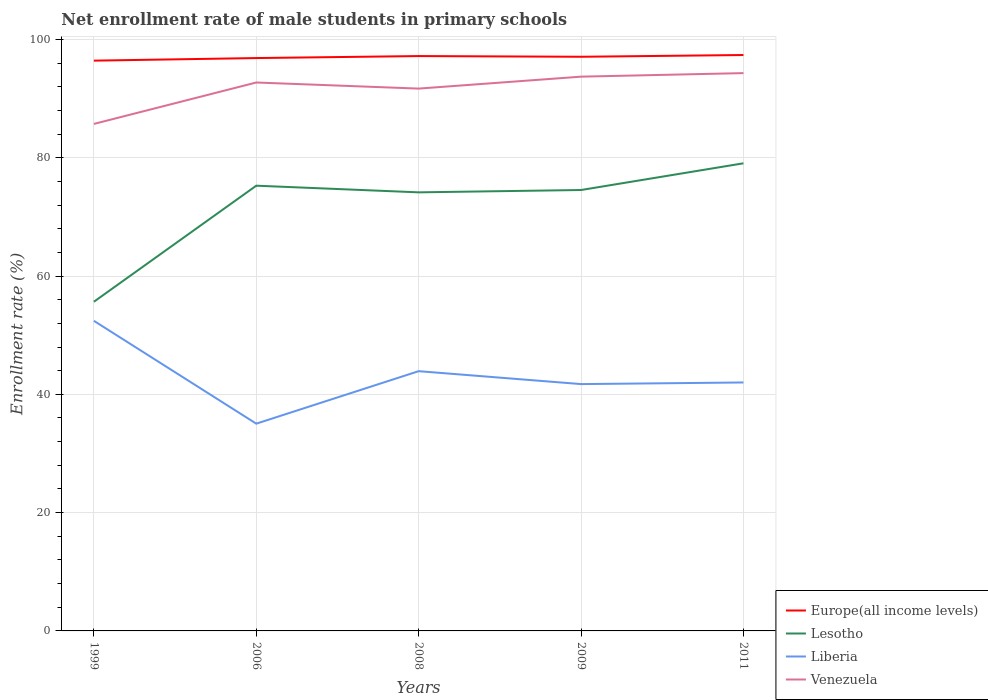Does the line corresponding to Europe(all income levels) intersect with the line corresponding to Lesotho?
Offer a very short reply. No. Across all years, what is the maximum net enrollment rate of male students in primary schools in Europe(all income levels)?
Your answer should be compact. 96.42. In which year was the net enrollment rate of male students in primary schools in Venezuela maximum?
Offer a very short reply. 1999. What is the total net enrollment rate of male students in primary schools in Venezuela in the graph?
Provide a succinct answer. -2.62. What is the difference between the highest and the second highest net enrollment rate of male students in primary schools in Europe(all income levels)?
Your response must be concise. 0.95. How many years are there in the graph?
Your answer should be very brief. 5. Are the values on the major ticks of Y-axis written in scientific E-notation?
Make the answer very short. No. Where does the legend appear in the graph?
Offer a terse response. Bottom right. How are the legend labels stacked?
Your answer should be compact. Vertical. What is the title of the graph?
Your response must be concise. Net enrollment rate of male students in primary schools. Does "Congo (Republic)" appear as one of the legend labels in the graph?
Your answer should be very brief. No. What is the label or title of the X-axis?
Keep it short and to the point. Years. What is the label or title of the Y-axis?
Keep it short and to the point. Enrollment rate (%). What is the Enrollment rate (%) of Europe(all income levels) in 1999?
Provide a short and direct response. 96.42. What is the Enrollment rate (%) of Lesotho in 1999?
Your answer should be compact. 55.65. What is the Enrollment rate (%) of Liberia in 1999?
Give a very brief answer. 52.43. What is the Enrollment rate (%) of Venezuela in 1999?
Your answer should be compact. 85.72. What is the Enrollment rate (%) in Europe(all income levels) in 2006?
Provide a short and direct response. 96.86. What is the Enrollment rate (%) in Lesotho in 2006?
Make the answer very short. 75.28. What is the Enrollment rate (%) of Liberia in 2006?
Offer a terse response. 35.04. What is the Enrollment rate (%) in Venezuela in 2006?
Make the answer very short. 92.72. What is the Enrollment rate (%) in Europe(all income levels) in 2008?
Your answer should be compact. 97.19. What is the Enrollment rate (%) in Lesotho in 2008?
Offer a very short reply. 74.15. What is the Enrollment rate (%) in Liberia in 2008?
Offer a very short reply. 43.92. What is the Enrollment rate (%) of Venezuela in 2008?
Ensure brevity in your answer.  91.69. What is the Enrollment rate (%) of Europe(all income levels) in 2009?
Offer a terse response. 97.08. What is the Enrollment rate (%) in Lesotho in 2009?
Your response must be concise. 74.55. What is the Enrollment rate (%) of Liberia in 2009?
Provide a short and direct response. 41.73. What is the Enrollment rate (%) in Venezuela in 2009?
Your response must be concise. 93.71. What is the Enrollment rate (%) of Europe(all income levels) in 2011?
Offer a very short reply. 97.37. What is the Enrollment rate (%) in Lesotho in 2011?
Offer a very short reply. 79.06. What is the Enrollment rate (%) in Liberia in 2011?
Give a very brief answer. 42.01. What is the Enrollment rate (%) of Venezuela in 2011?
Ensure brevity in your answer.  94.31. Across all years, what is the maximum Enrollment rate (%) of Europe(all income levels)?
Ensure brevity in your answer.  97.37. Across all years, what is the maximum Enrollment rate (%) of Lesotho?
Your answer should be compact. 79.06. Across all years, what is the maximum Enrollment rate (%) in Liberia?
Ensure brevity in your answer.  52.43. Across all years, what is the maximum Enrollment rate (%) in Venezuela?
Ensure brevity in your answer.  94.31. Across all years, what is the minimum Enrollment rate (%) in Europe(all income levels)?
Offer a terse response. 96.42. Across all years, what is the minimum Enrollment rate (%) in Lesotho?
Ensure brevity in your answer.  55.65. Across all years, what is the minimum Enrollment rate (%) of Liberia?
Provide a short and direct response. 35.04. Across all years, what is the minimum Enrollment rate (%) in Venezuela?
Provide a succinct answer. 85.72. What is the total Enrollment rate (%) of Europe(all income levels) in the graph?
Give a very brief answer. 484.92. What is the total Enrollment rate (%) of Lesotho in the graph?
Provide a succinct answer. 358.69. What is the total Enrollment rate (%) in Liberia in the graph?
Ensure brevity in your answer.  215.13. What is the total Enrollment rate (%) of Venezuela in the graph?
Keep it short and to the point. 458.16. What is the difference between the Enrollment rate (%) of Europe(all income levels) in 1999 and that in 2006?
Give a very brief answer. -0.43. What is the difference between the Enrollment rate (%) in Lesotho in 1999 and that in 2006?
Ensure brevity in your answer.  -19.63. What is the difference between the Enrollment rate (%) in Liberia in 1999 and that in 2006?
Your answer should be compact. 17.39. What is the difference between the Enrollment rate (%) in Venezuela in 1999 and that in 2006?
Ensure brevity in your answer.  -7. What is the difference between the Enrollment rate (%) in Europe(all income levels) in 1999 and that in 2008?
Give a very brief answer. -0.77. What is the difference between the Enrollment rate (%) in Lesotho in 1999 and that in 2008?
Provide a short and direct response. -18.5. What is the difference between the Enrollment rate (%) of Liberia in 1999 and that in 2008?
Your response must be concise. 8.51. What is the difference between the Enrollment rate (%) of Venezuela in 1999 and that in 2008?
Your answer should be very brief. -5.97. What is the difference between the Enrollment rate (%) in Europe(all income levels) in 1999 and that in 2009?
Provide a short and direct response. -0.66. What is the difference between the Enrollment rate (%) in Lesotho in 1999 and that in 2009?
Offer a terse response. -18.89. What is the difference between the Enrollment rate (%) of Liberia in 1999 and that in 2009?
Provide a short and direct response. 10.7. What is the difference between the Enrollment rate (%) in Venezuela in 1999 and that in 2009?
Ensure brevity in your answer.  -7.99. What is the difference between the Enrollment rate (%) in Europe(all income levels) in 1999 and that in 2011?
Your answer should be compact. -0.95. What is the difference between the Enrollment rate (%) in Lesotho in 1999 and that in 2011?
Make the answer very short. -23.41. What is the difference between the Enrollment rate (%) in Liberia in 1999 and that in 2011?
Give a very brief answer. 10.42. What is the difference between the Enrollment rate (%) in Venezuela in 1999 and that in 2011?
Keep it short and to the point. -8.59. What is the difference between the Enrollment rate (%) in Europe(all income levels) in 2006 and that in 2008?
Ensure brevity in your answer.  -0.34. What is the difference between the Enrollment rate (%) of Lesotho in 2006 and that in 2008?
Make the answer very short. 1.13. What is the difference between the Enrollment rate (%) in Liberia in 2006 and that in 2008?
Give a very brief answer. -8.88. What is the difference between the Enrollment rate (%) in Venezuela in 2006 and that in 2008?
Offer a terse response. 1.03. What is the difference between the Enrollment rate (%) of Europe(all income levels) in 2006 and that in 2009?
Provide a short and direct response. -0.22. What is the difference between the Enrollment rate (%) of Lesotho in 2006 and that in 2009?
Your answer should be very brief. 0.73. What is the difference between the Enrollment rate (%) in Liberia in 2006 and that in 2009?
Offer a very short reply. -6.69. What is the difference between the Enrollment rate (%) of Venezuela in 2006 and that in 2009?
Ensure brevity in your answer.  -0.99. What is the difference between the Enrollment rate (%) of Europe(all income levels) in 2006 and that in 2011?
Your answer should be very brief. -0.52. What is the difference between the Enrollment rate (%) in Lesotho in 2006 and that in 2011?
Your answer should be very brief. -3.78. What is the difference between the Enrollment rate (%) in Liberia in 2006 and that in 2011?
Keep it short and to the point. -6.97. What is the difference between the Enrollment rate (%) in Venezuela in 2006 and that in 2011?
Your answer should be compact. -1.59. What is the difference between the Enrollment rate (%) in Europe(all income levels) in 2008 and that in 2009?
Provide a short and direct response. 0.12. What is the difference between the Enrollment rate (%) of Lesotho in 2008 and that in 2009?
Ensure brevity in your answer.  -0.39. What is the difference between the Enrollment rate (%) of Liberia in 2008 and that in 2009?
Provide a short and direct response. 2.18. What is the difference between the Enrollment rate (%) in Venezuela in 2008 and that in 2009?
Your response must be concise. -2.02. What is the difference between the Enrollment rate (%) of Europe(all income levels) in 2008 and that in 2011?
Ensure brevity in your answer.  -0.18. What is the difference between the Enrollment rate (%) of Lesotho in 2008 and that in 2011?
Provide a short and direct response. -4.91. What is the difference between the Enrollment rate (%) in Liberia in 2008 and that in 2011?
Give a very brief answer. 1.91. What is the difference between the Enrollment rate (%) of Venezuela in 2008 and that in 2011?
Provide a short and direct response. -2.62. What is the difference between the Enrollment rate (%) of Europe(all income levels) in 2009 and that in 2011?
Give a very brief answer. -0.3. What is the difference between the Enrollment rate (%) in Lesotho in 2009 and that in 2011?
Your answer should be very brief. -4.51. What is the difference between the Enrollment rate (%) of Liberia in 2009 and that in 2011?
Your answer should be compact. -0.28. What is the difference between the Enrollment rate (%) of Europe(all income levels) in 1999 and the Enrollment rate (%) of Lesotho in 2006?
Provide a short and direct response. 21.14. What is the difference between the Enrollment rate (%) of Europe(all income levels) in 1999 and the Enrollment rate (%) of Liberia in 2006?
Offer a terse response. 61.38. What is the difference between the Enrollment rate (%) of Europe(all income levels) in 1999 and the Enrollment rate (%) of Venezuela in 2006?
Provide a short and direct response. 3.7. What is the difference between the Enrollment rate (%) in Lesotho in 1999 and the Enrollment rate (%) in Liberia in 2006?
Make the answer very short. 20.61. What is the difference between the Enrollment rate (%) in Lesotho in 1999 and the Enrollment rate (%) in Venezuela in 2006?
Give a very brief answer. -37.07. What is the difference between the Enrollment rate (%) of Liberia in 1999 and the Enrollment rate (%) of Venezuela in 2006?
Your answer should be very brief. -40.29. What is the difference between the Enrollment rate (%) in Europe(all income levels) in 1999 and the Enrollment rate (%) in Lesotho in 2008?
Your response must be concise. 22.27. What is the difference between the Enrollment rate (%) in Europe(all income levels) in 1999 and the Enrollment rate (%) in Liberia in 2008?
Your answer should be compact. 52.5. What is the difference between the Enrollment rate (%) of Europe(all income levels) in 1999 and the Enrollment rate (%) of Venezuela in 2008?
Ensure brevity in your answer.  4.73. What is the difference between the Enrollment rate (%) of Lesotho in 1999 and the Enrollment rate (%) of Liberia in 2008?
Offer a very short reply. 11.74. What is the difference between the Enrollment rate (%) in Lesotho in 1999 and the Enrollment rate (%) in Venezuela in 2008?
Offer a terse response. -36.04. What is the difference between the Enrollment rate (%) in Liberia in 1999 and the Enrollment rate (%) in Venezuela in 2008?
Give a very brief answer. -39.26. What is the difference between the Enrollment rate (%) in Europe(all income levels) in 1999 and the Enrollment rate (%) in Lesotho in 2009?
Your answer should be very brief. 21.87. What is the difference between the Enrollment rate (%) of Europe(all income levels) in 1999 and the Enrollment rate (%) of Liberia in 2009?
Keep it short and to the point. 54.69. What is the difference between the Enrollment rate (%) of Europe(all income levels) in 1999 and the Enrollment rate (%) of Venezuela in 2009?
Provide a short and direct response. 2.71. What is the difference between the Enrollment rate (%) of Lesotho in 1999 and the Enrollment rate (%) of Liberia in 2009?
Make the answer very short. 13.92. What is the difference between the Enrollment rate (%) in Lesotho in 1999 and the Enrollment rate (%) in Venezuela in 2009?
Your response must be concise. -38.06. What is the difference between the Enrollment rate (%) in Liberia in 1999 and the Enrollment rate (%) in Venezuela in 2009?
Ensure brevity in your answer.  -41.28. What is the difference between the Enrollment rate (%) in Europe(all income levels) in 1999 and the Enrollment rate (%) in Lesotho in 2011?
Your response must be concise. 17.36. What is the difference between the Enrollment rate (%) in Europe(all income levels) in 1999 and the Enrollment rate (%) in Liberia in 2011?
Provide a short and direct response. 54.41. What is the difference between the Enrollment rate (%) of Europe(all income levels) in 1999 and the Enrollment rate (%) of Venezuela in 2011?
Your answer should be compact. 2.11. What is the difference between the Enrollment rate (%) of Lesotho in 1999 and the Enrollment rate (%) of Liberia in 2011?
Offer a terse response. 13.65. What is the difference between the Enrollment rate (%) in Lesotho in 1999 and the Enrollment rate (%) in Venezuela in 2011?
Offer a very short reply. -38.66. What is the difference between the Enrollment rate (%) in Liberia in 1999 and the Enrollment rate (%) in Venezuela in 2011?
Offer a terse response. -41.88. What is the difference between the Enrollment rate (%) of Europe(all income levels) in 2006 and the Enrollment rate (%) of Lesotho in 2008?
Give a very brief answer. 22.7. What is the difference between the Enrollment rate (%) of Europe(all income levels) in 2006 and the Enrollment rate (%) of Liberia in 2008?
Ensure brevity in your answer.  52.94. What is the difference between the Enrollment rate (%) in Europe(all income levels) in 2006 and the Enrollment rate (%) in Venezuela in 2008?
Offer a terse response. 5.16. What is the difference between the Enrollment rate (%) in Lesotho in 2006 and the Enrollment rate (%) in Liberia in 2008?
Give a very brief answer. 31.36. What is the difference between the Enrollment rate (%) of Lesotho in 2006 and the Enrollment rate (%) of Venezuela in 2008?
Your answer should be compact. -16.41. What is the difference between the Enrollment rate (%) in Liberia in 2006 and the Enrollment rate (%) in Venezuela in 2008?
Make the answer very short. -56.65. What is the difference between the Enrollment rate (%) in Europe(all income levels) in 2006 and the Enrollment rate (%) in Lesotho in 2009?
Give a very brief answer. 22.31. What is the difference between the Enrollment rate (%) of Europe(all income levels) in 2006 and the Enrollment rate (%) of Liberia in 2009?
Keep it short and to the point. 55.12. What is the difference between the Enrollment rate (%) of Europe(all income levels) in 2006 and the Enrollment rate (%) of Venezuela in 2009?
Ensure brevity in your answer.  3.14. What is the difference between the Enrollment rate (%) in Lesotho in 2006 and the Enrollment rate (%) in Liberia in 2009?
Your response must be concise. 33.55. What is the difference between the Enrollment rate (%) of Lesotho in 2006 and the Enrollment rate (%) of Venezuela in 2009?
Offer a very short reply. -18.43. What is the difference between the Enrollment rate (%) in Liberia in 2006 and the Enrollment rate (%) in Venezuela in 2009?
Ensure brevity in your answer.  -58.67. What is the difference between the Enrollment rate (%) of Europe(all income levels) in 2006 and the Enrollment rate (%) of Lesotho in 2011?
Keep it short and to the point. 17.79. What is the difference between the Enrollment rate (%) in Europe(all income levels) in 2006 and the Enrollment rate (%) in Liberia in 2011?
Keep it short and to the point. 54.85. What is the difference between the Enrollment rate (%) in Europe(all income levels) in 2006 and the Enrollment rate (%) in Venezuela in 2011?
Your answer should be very brief. 2.54. What is the difference between the Enrollment rate (%) in Lesotho in 2006 and the Enrollment rate (%) in Liberia in 2011?
Your answer should be compact. 33.27. What is the difference between the Enrollment rate (%) of Lesotho in 2006 and the Enrollment rate (%) of Venezuela in 2011?
Your response must be concise. -19.03. What is the difference between the Enrollment rate (%) in Liberia in 2006 and the Enrollment rate (%) in Venezuela in 2011?
Make the answer very short. -59.27. What is the difference between the Enrollment rate (%) in Europe(all income levels) in 2008 and the Enrollment rate (%) in Lesotho in 2009?
Make the answer very short. 22.65. What is the difference between the Enrollment rate (%) in Europe(all income levels) in 2008 and the Enrollment rate (%) in Liberia in 2009?
Keep it short and to the point. 55.46. What is the difference between the Enrollment rate (%) of Europe(all income levels) in 2008 and the Enrollment rate (%) of Venezuela in 2009?
Provide a succinct answer. 3.48. What is the difference between the Enrollment rate (%) in Lesotho in 2008 and the Enrollment rate (%) in Liberia in 2009?
Keep it short and to the point. 32.42. What is the difference between the Enrollment rate (%) of Lesotho in 2008 and the Enrollment rate (%) of Venezuela in 2009?
Offer a very short reply. -19.56. What is the difference between the Enrollment rate (%) of Liberia in 2008 and the Enrollment rate (%) of Venezuela in 2009?
Offer a very short reply. -49.8. What is the difference between the Enrollment rate (%) in Europe(all income levels) in 2008 and the Enrollment rate (%) in Lesotho in 2011?
Your answer should be compact. 18.13. What is the difference between the Enrollment rate (%) of Europe(all income levels) in 2008 and the Enrollment rate (%) of Liberia in 2011?
Keep it short and to the point. 55.19. What is the difference between the Enrollment rate (%) in Europe(all income levels) in 2008 and the Enrollment rate (%) in Venezuela in 2011?
Make the answer very short. 2.88. What is the difference between the Enrollment rate (%) of Lesotho in 2008 and the Enrollment rate (%) of Liberia in 2011?
Your answer should be compact. 32.15. What is the difference between the Enrollment rate (%) of Lesotho in 2008 and the Enrollment rate (%) of Venezuela in 2011?
Provide a short and direct response. -20.16. What is the difference between the Enrollment rate (%) in Liberia in 2008 and the Enrollment rate (%) in Venezuela in 2011?
Give a very brief answer. -50.4. What is the difference between the Enrollment rate (%) of Europe(all income levels) in 2009 and the Enrollment rate (%) of Lesotho in 2011?
Your response must be concise. 18.01. What is the difference between the Enrollment rate (%) of Europe(all income levels) in 2009 and the Enrollment rate (%) of Liberia in 2011?
Your answer should be compact. 55.07. What is the difference between the Enrollment rate (%) in Europe(all income levels) in 2009 and the Enrollment rate (%) in Venezuela in 2011?
Ensure brevity in your answer.  2.76. What is the difference between the Enrollment rate (%) in Lesotho in 2009 and the Enrollment rate (%) in Liberia in 2011?
Offer a very short reply. 32.54. What is the difference between the Enrollment rate (%) in Lesotho in 2009 and the Enrollment rate (%) in Venezuela in 2011?
Give a very brief answer. -19.76. What is the difference between the Enrollment rate (%) in Liberia in 2009 and the Enrollment rate (%) in Venezuela in 2011?
Make the answer very short. -52.58. What is the average Enrollment rate (%) of Europe(all income levels) per year?
Give a very brief answer. 96.98. What is the average Enrollment rate (%) in Lesotho per year?
Ensure brevity in your answer.  71.74. What is the average Enrollment rate (%) of Liberia per year?
Ensure brevity in your answer.  43.03. What is the average Enrollment rate (%) in Venezuela per year?
Give a very brief answer. 91.63. In the year 1999, what is the difference between the Enrollment rate (%) of Europe(all income levels) and Enrollment rate (%) of Lesotho?
Provide a succinct answer. 40.77. In the year 1999, what is the difference between the Enrollment rate (%) in Europe(all income levels) and Enrollment rate (%) in Liberia?
Provide a succinct answer. 43.99. In the year 1999, what is the difference between the Enrollment rate (%) in Europe(all income levels) and Enrollment rate (%) in Venezuela?
Offer a very short reply. 10.7. In the year 1999, what is the difference between the Enrollment rate (%) in Lesotho and Enrollment rate (%) in Liberia?
Your answer should be compact. 3.22. In the year 1999, what is the difference between the Enrollment rate (%) in Lesotho and Enrollment rate (%) in Venezuela?
Ensure brevity in your answer.  -30.07. In the year 1999, what is the difference between the Enrollment rate (%) of Liberia and Enrollment rate (%) of Venezuela?
Make the answer very short. -33.29. In the year 2006, what is the difference between the Enrollment rate (%) of Europe(all income levels) and Enrollment rate (%) of Lesotho?
Give a very brief answer. 21.58. In the year 2006, what is the difference between the Enrollment rate (%) in Europe(all income levels) and Enrollment rate (%) in Liberia?
Give a very brief answer. 61.81. In the year 2006, what is the difference between the Enrollment rate (%) of Europe(all income levels) and Enrollment rate (%) of Venezuela?
Provide a succinct answer. 4.13. In the year 2006, what is the difference between the Enrollment rate (%) of Lesotho and Enrollment rate (%) of Liberia?
Offer a very short reply. 40.24. In the year 2006, what is the difference between the Enrollment rate (%) in Lesotho and Enrollment rate (%) in Venezuela?
Provide a short and direct response. -17.45. In the year 2006, what is the difference between the Enrollment rate (%) in Liberia and Enrollment rate (%) in Venezuela?
Your response must be concise. -57.68. In the year 2008, what is the difference between the Enrollment rate (%) of Europe(all income levels) and Enrollment rate (%) of Lesotho?
Provide a short and direct response. 23.04. In the year 2008, what is the difference between the Enrollment rate (%) of Europe(all income levels) and Enrollment rate (%) of Liberia?
Your answer should be compact. 53.28. In the year 2008, what is the difference between the Enrollment rate (%) in Europe(all income levels) and Enrollment rate (%) in Venezuela?
Your answer should be very brief. 5.5. In the year 2008, what is the difference between the Enrollment rate (%) of Lesotho and Enrollment rate (%) of Liberia?
Make the answer very short. 30.24. In the year 2008, what is the difference between the Enrollment rate (%) in Lesotho and Enrollment rate (%) in Venezuela?
Make the answer very short. -17.54. In the year 2008, what is the difference between the Enrollment rate (%) in Liberia and Enrollment rate (%) in Venezuela?
Ensure brevity in your answer.  -47.78. In the year 2009, what is the difference between the Enrollment rate (%) of Europe(all income levels) and Enrollment rate (%) of Lesotho?
Offer a very short reply. 22.53. In the year 2009, what is the difference between the Enrollment rate (%) of Europe(all income levels) and Enrollment rate (%) of Liberia?
Ensure brevity in your answer.  55.34. In the year 2009, what is the difference between the Enrollment rate (%) of Europe(all income levels) and Enrollment rate (%) of Venezuela?
Your response must be concise. 3.36. In the year 2009, what is the difference between the Enrollment rate (%) in Lesotho and Enrollment rate (%) in Liberia?
Your answer should be compact. 32.82. In the year 2009, what is the difference between the Enrollment rate (%) of Lesotho and Enrollment rate (%) of Venezuela?
Give a very brief answer. -19.16. In the year 2009, what is the difference between the Enrollment rate (%) of Liberia and Enrollment rate (%) of Venezuela?
Provide a succinct answer. -51.98. In the year 2011, what is the difference between the Enrollment rate (%) in Europe(all income levels) and Enrollment rate (%) in Lesotho?
Make the answer very short. 18.31. In the year 2011, what is the difference between the Enrollment rate (%) in Europe(all income levels) and Enrollment rate (%) in Liberia?
Give a very brief answer. 55.36. In the year 2011, what is the difference between the Enrollment rate (%) of Europe(all income levels) and Enrollment rate (%) of Venezuela?
Your answer should be very brief. 3.06. In the year 2011, what is the difference between the Enrollment rate (%) in Lesotho and Enrollment rate (%) in Liberia?
Keep it short and to the point. 37.05. In the year 2011, what is the difference between the Enrollment rate (%) of Lesotho and Enrollment rate (%) of Venezuela?
Your response must be concise. -15.25. In the year 2011, what is the difference between the Enrollment rate (%) in Liberia and Enrollment rate (%) in Venezuela?
Offer a terse response. -52.3. What is the ratio of the Enrollment rate (%) of Europe(all income levels) in 1999 to that in 2006?
Your response must be concise. 1. What is the ratio of the Enrollment rate (%) of Lesotho in 1999 to that in 2006?
Your answer should be compact. 0.74. What is the ratio of the Enrollment rate (%) in Liberia in 1999 to that in 2006?
Your response must be concise. 1.5. What is the ratio of the Enrollment rate (%) of Venezuela in 1999 to that in 2006?
Your answer should be very brief. 0.92. What is the ratio of the Enrollment rate (%) in Europe(all income levels) in 1999 to that in 2008?
Your answer should be very brief. 0.99. What is the ratio of the Enrollment rate (%) of Lesotho in 1999 to that in 2008?
Offer a terse response. 0.75. What is the ratio of the Enrollment rate (%) of Liberia in 1999 to that in 2008?
Your answer should be compact. 1.19. What is the ratio of the Enrollment rate (%) in Venezuela in 1999 to that in 2008?
Offer a terse response. 0.93. What is the ratio of the Enrollment rate (%) in Lesotho in 1999 to that in 2009?
Ensure brevity in your answer.  0.75. What is the ratio of the Enrollment rate (%) of Liberia in 1999 to that in 2009?
Your response must be concise. 1.26. What is the ratio of the Enrollment rate (%) of Venezuela in 1999 to that in 2009?
Your answer should be compact. 0.91. What is the ratio of the Enrollment rate (%) in Europe(all income levels) in 1999 to that in 2011?
Your response must be concise. 0.99. What is the ratio of the Enrollment rate (%) of Lesotho in 1999 to that in 2011?
Make the answer very short. 0.7. What is the ratio of the Enrollment rate (%) in Liberia in 1999 to that in 2011?
Give a very brief answer. 1.25. What is the ratio of the Enrollment rate (%) of Venezuela in 1999 to that in 2011?
Your answer should be very brief. 0.91. What is the ratio of the Enrollment rate (%) of Lesotho in 2006 to that in 2008?
Your answer should be very brief. 1.02. What is the ratio of the Enrollment rate (%) in Liberia in 2006 to that in 2008?
Keep it short and to the point. 0.8. What is the ratio of the Enrollment rate (%) of Venezuela in 2006 to that in 2008?
Give a very brief answer. 1.01. What is the ratio of the Enrollment rate (%) of Europe(all income levels) in 2006 to that in 2009?
Provide a short and direct response. 1. What is the ratio of the Enrollment rate (%) of Lesotho in 2006 to that in 2009?
Make the answer very short. 1.01. What is the ratio of the Enrollment rate (%) in Liberia in 2006 to that in 2009?
Offer a terse response. 0.84. What is the ratio of the Enrollment rate (%) of Venezuela in 2006 to that in 2009?
Your answer should be compact. 0.99. What is the ratio of the Enrollment rate (%) in Europe(all income levels) in 2006 to that in 2011?
Give a very brief answer. 0.99. What is the ratio of the Enrollment rate (%) of Lesotho in 2006 to that in 2011?
Provide a succinct answer. 0.95. What is the ratio of the Enrollment rate (%) in Liberia in 2006 to that in 2011?
Provide a succinct answer. 0.83. What is the ratio of the Enrollment rate (%) of Venezuela in 2006 to that in 2011?
Your answer should be very brief. 0.98. What is the ratio of the Enrollment rate (%) of Liberia in 2008 to that in 2009?
Offer a very short reply. 1.05. What is the ratio of the Enrollment rate (%) of Venezuela in 2008 to that in 2009?
Your response must be concise. 0.98. What is the ratio of the Enrollment rate (%) of Lesotho in 2008 to that in 2011?
Provide a short and direct response. 0.94. What is the ratio of the Enrollment rate (%) in Liberia in 2008 to that in 2011?
Offer a terse response. 1.05. What is the ratio of the Enrollment rate (%) of Venezuela in 2008 to that in 2011?
Your response must be concise. 0.97. What is the ratio of the Enrollment rate (%) in Europe(all income levels) in 2009 to that in 2011?
Your response must be concise. 1. What is the ratio of the Enrollment rate (%) in Lesotho in 2009 to that in 2011?
Give a very brief answer. 0.94. What is the ratio of the Enrollment rate (%) of Venezuela in 2009 to that in 2011?
Offer a very short reply. 0.99. What is the difference between the highest and the second highest Enrollment rate (%) in Europe(all income levels)?
Your response must be concise. 0.18. What is the difference between the highest and the second highest Enrollment rate (%) in Lesotho?
Your answer should be compact. 3.78. What is the difference between the highest and the second highest Enrollment rate (%) in Liberia?
Offer a terse response. 8.51. What is the difference between the highest and the second highest Enrollment rate (%) in Venezuela?
Offer a terse response. 0.6. What is the difference between the highest and the lowest Enrollment rate (%) in Europe(all income levels)?
Ensure brevity in your answer.  0.95. What is the difference between the highest and the lowest Enrollment rate (%) of Lesotho?
Your response must be concise. 23.41. What is the difference between the highest and the lowest Enrollment rate (%) of Liberia?
Provide a short and direct response. 17.39. What is the difference between the highest and the lowest Enrollment rate (%) in Venezuela?
Provide a short and direct response. 8.59. 